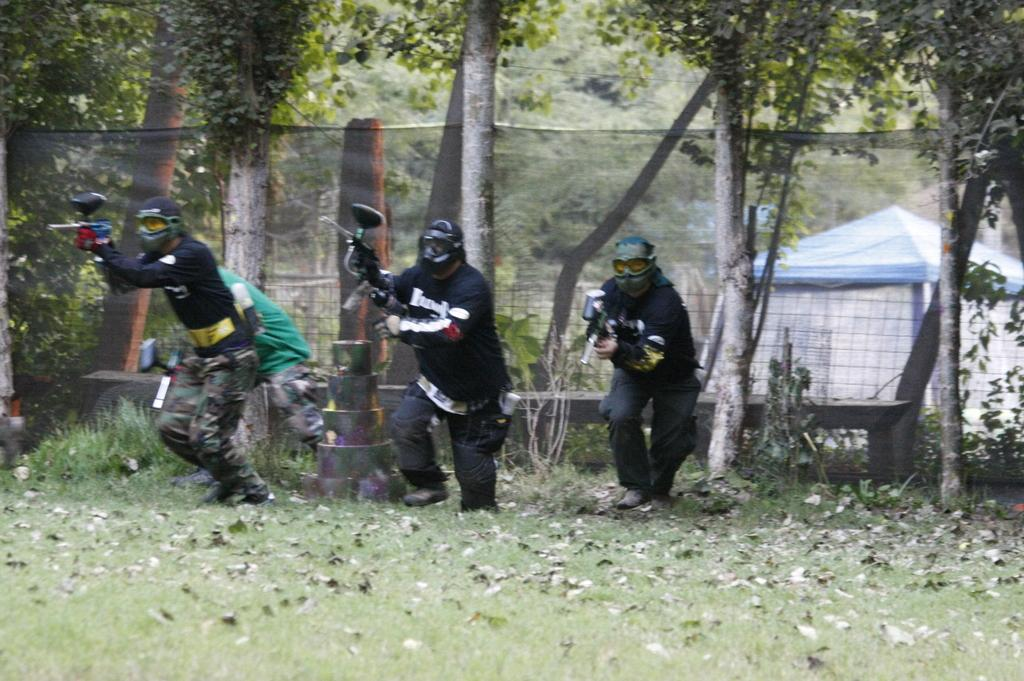How many people are in the image? There are three men in the image. What are the men wearing on their faces? The men are wearing masks. What are the men doing in the image? The men are running on grassland. What can be seen in the background of the image? There is a fence and trees visible behind the fence. What type of wren can be seen perched on the fence in the image? There is no wren present in the image; the men are the main subjects in the image. How many times do the men sneeze while running in the image? The image does not provide information about the men sneezing, so it cannot be determined from the image. 